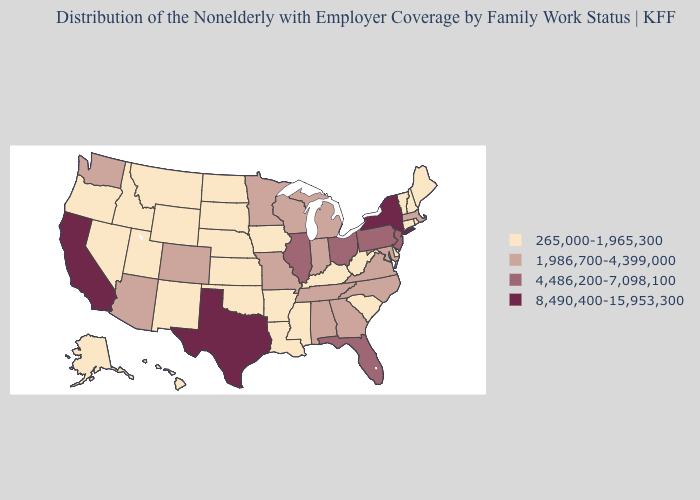Does the first symbol in the legend represent the smallest category?
Give a very brief answer. Yes. What is the lowest value in the South?
Short answer required. 265,000-1,965,300. What is the value of Oklahoma?
Quick response, please. 265,000-1,965,300. Does California have the highest value in the West?
Concise answer only. Yes. Name the states that have a value in the range 4,486,200-7,098,100?
Short answer required. Florida, Illinois, New Jersey, Ohio, Pennsylvania. What is the value of Illinois?
Keep it brief. 4,486,200-7,098,100. What is the highest value in the West ?
Concise answer only. 8,490,400-15,953,300. Which states have the highest value in the USA?
Short answer required. California, New York, Texas. Which states have the highest value in the USA?
Short answer required. California, New York, Texas. Does New York have the highest value in the USA?
Keep it brief. Yes. Does the first symbol in the legend represent the smallest category?
Give a very brief answer. Yes. Does Oklahoma have the lowest value in the South?
Short answer required. Yes. Does Texas have the highest value in the South?
Concise answer only. Yes. Which states have the lowest value in the South?
Quick response, please. Arkansas, Delaware, Kentucky, Louisiana, Mississippi, Oklahoma, South Carolina, West Virginia. Name the states that have a value in the range 8,490,400-15,953,300?
Write a very short answer. California, New York, Texas. 